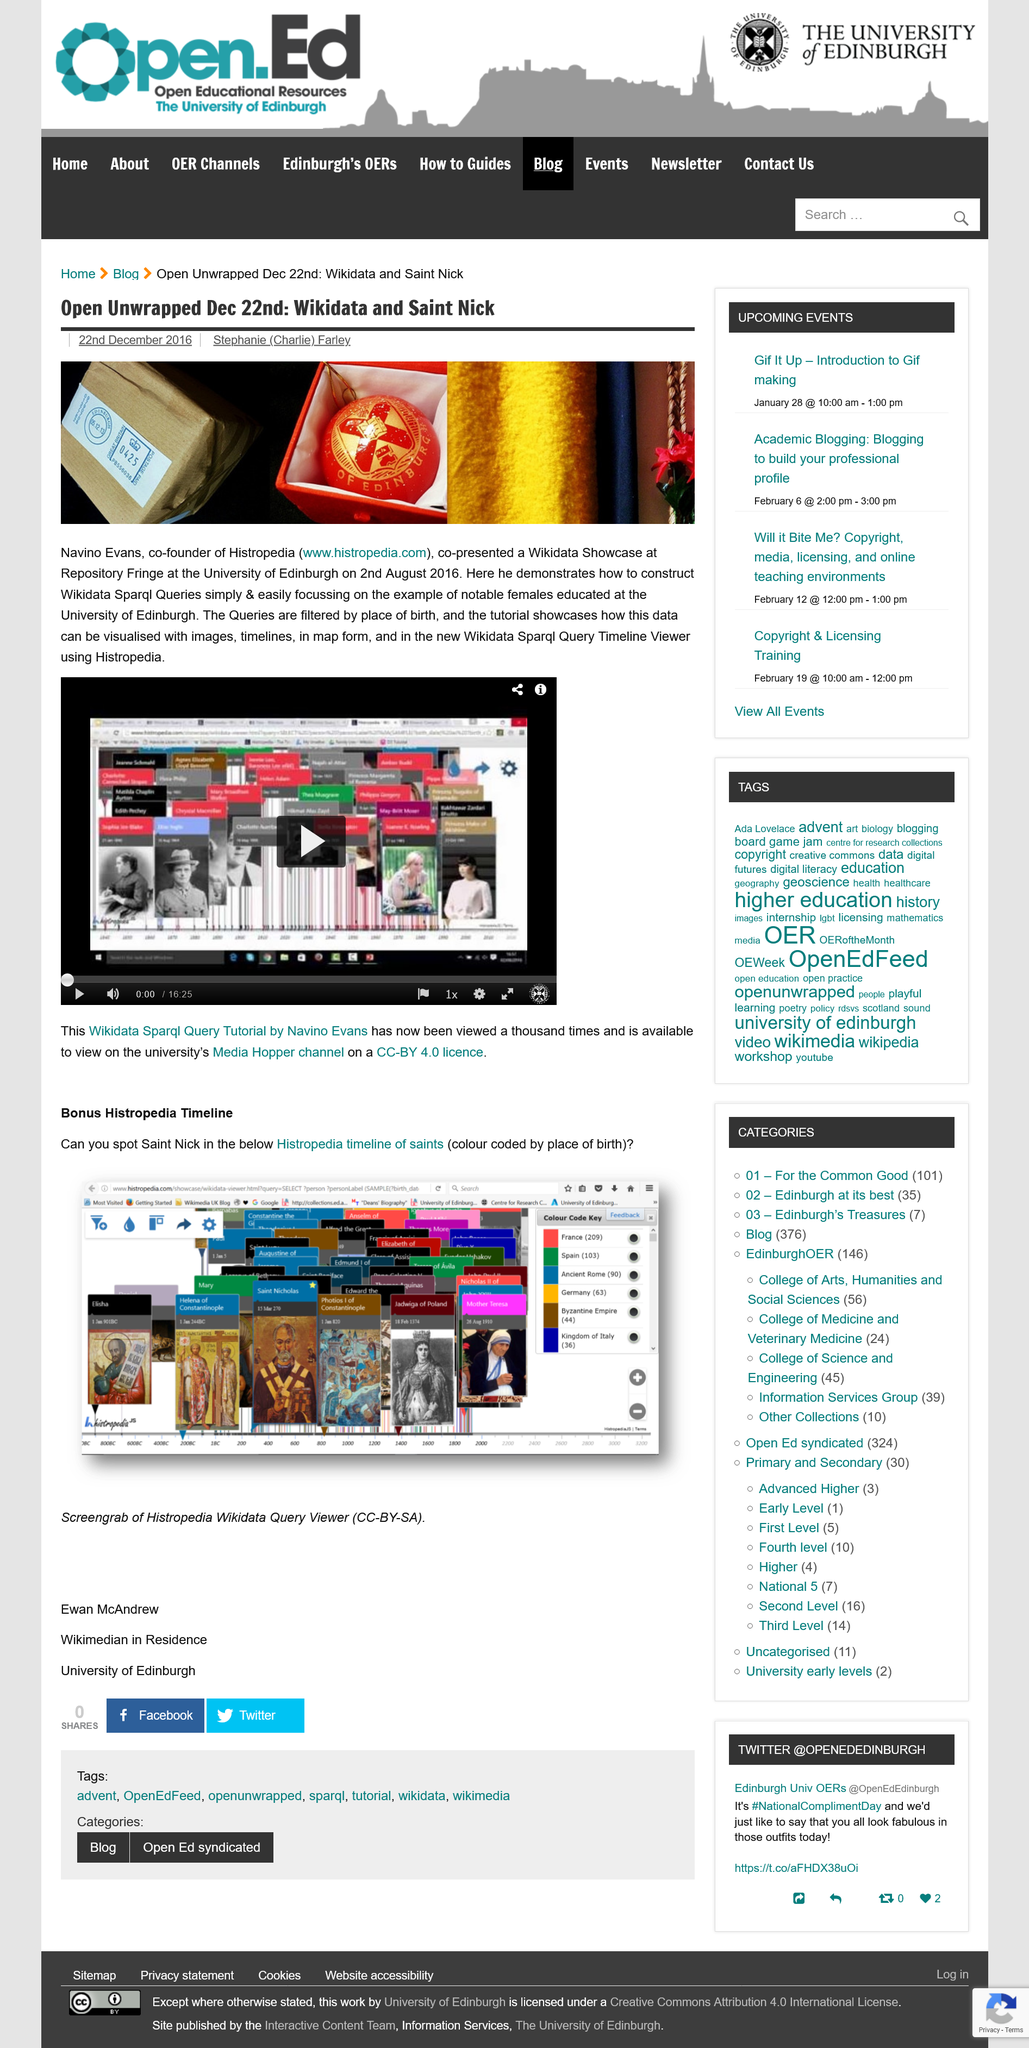Indicate a few pertinent items in this graphic. The University of Edinburgh is shown in the image. On December 22nd, 2016, Stephanie (Charlie) Farley reported that the current outlook for the market is positive. Navino Evans is a co-founder of Histropedia, as stated in the text. 